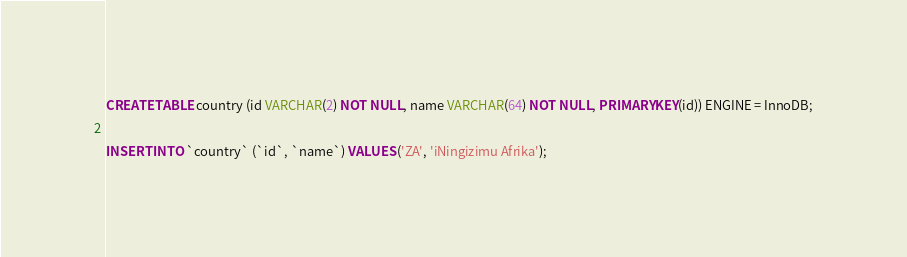Convert code to text. <code><loc_0><loc_0><loc_500><loc_500><_SQL_>CREATE TABLE country (id VARCHAR(2) NOT NULL, name VARCHAR(64) NOT NULL, PRIMARY KEY(id)) ENGINE = InnoDB;

INSERT INTO `country` (`id`, `name`) VALUES ('ZA', 'iNingizimu Afrika');
</code> 